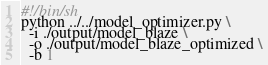<code> <loc_0><loc_0><loc_500><loc_500><_Bash_>#!/bin/sh
python ../../model_optimizer.py \
  -i ./output/model_blaze \
  -o ./output/model_blaze_optimized \
  -b 1
</code> 